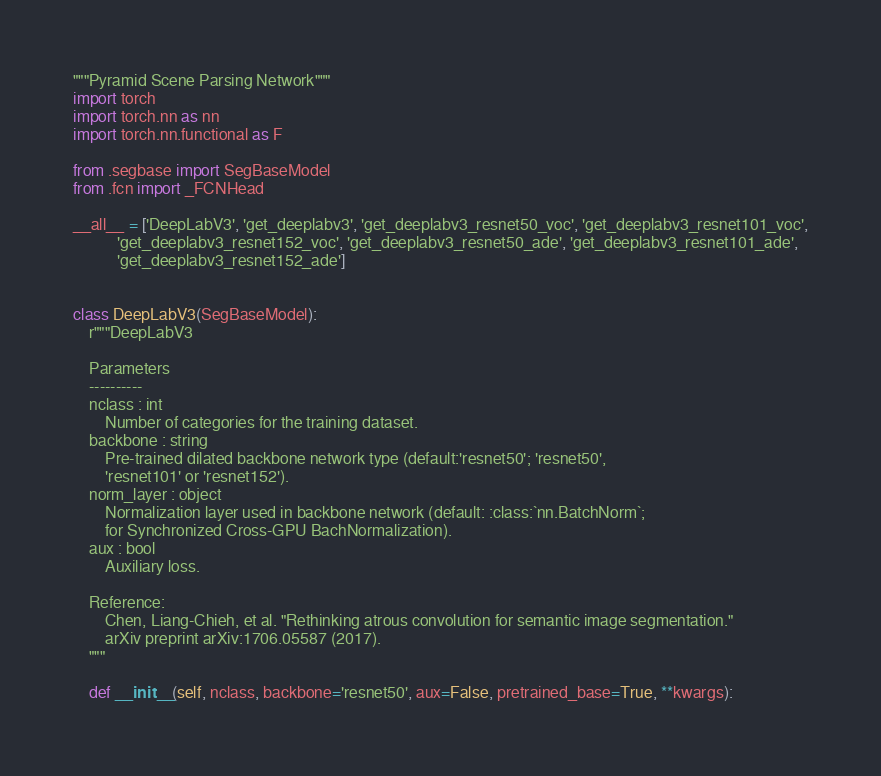Convert code to text. <code><loc_0><loc_0><loc_500><loc_500><_Python_>"""Pyramid Scene Parsing Network"""
import torch
import torch.nn as nn
import torch.nn.functional as F

from .segbase import SegBaseModel
from .fcn import _FCNHead

__all__ = ['DeepLabV3', 'get_deeplabv3', 'get_deeplabv3_resnet50_voc', 'get_deeplabv3_resnet101_voc',
           'get_deeplabv3_resnet152_voc', 'get_deeplabv3_resnet50_ade', 'get_deeplabv3_resnet101_ade',
           'get_deeplabv3_resnet152_ade']


class DeepLabV3(SegBaseModel):
    r"""DeepLabV3

    Parameters
    ----------
    nclass : int
        Number of categories for the training dataset.
    backbone : string
        Pre-trained dilated backbone network type (default:'resnet50'; 'resnet50',
        'resnet101' or 'resnet152').
    norm_layer : object
        Normalization layer used in backbone network (default: :class:`nn.BatchNorm`;
        for Synchronized Cross-GPU BachNormalization).
    aux : bool
        Auxiliary loss.

    Reference:
        Chen, Liang-Chieh, et al. "Rethinking atrous convolution for semantic image segmentation."
        arXiv preprint arXiv:1706.05587 (2017).
    """

    def __init__(self, nclass, backbone='resnet50', aux=False, pretrained_base=True, **kwargs):</code> 